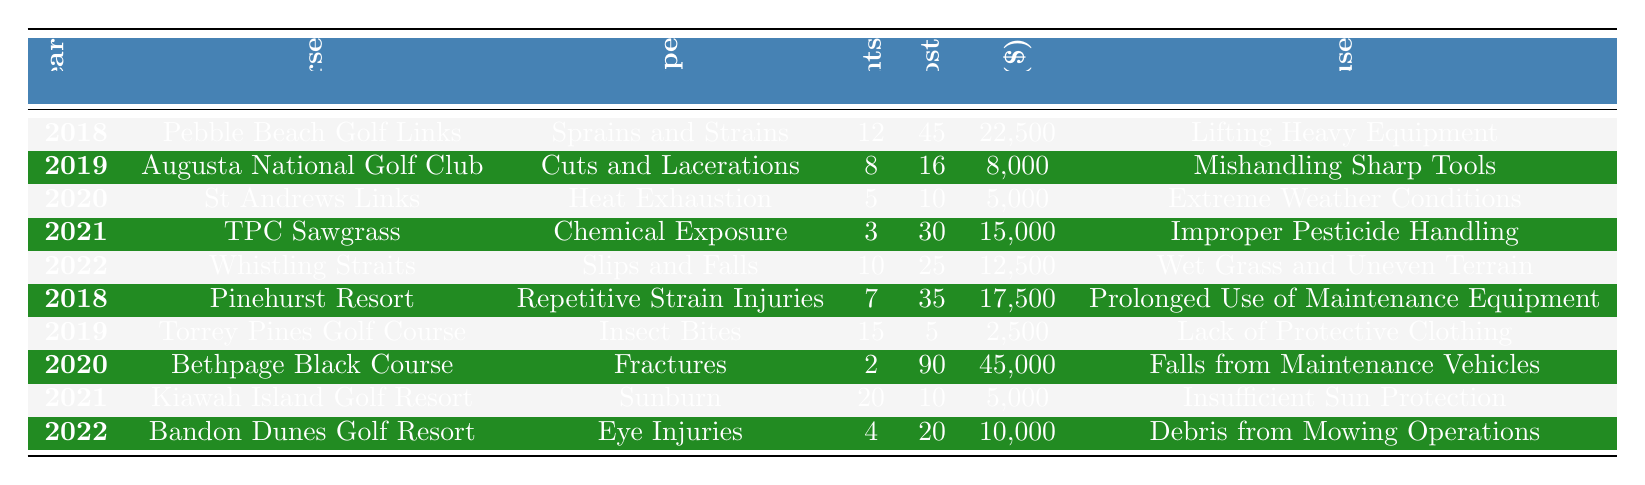What is the total number of incidents reported in 2019? The table shows that there were 8 incidents at Augusta National Golf Club and 15 incidents at Torrey Pines Golf Course in 2019. Adding these two gives 8 + 15 = 23.
Answer: 23 What type of injury had the highest cost to the golf course? Looking at the costs, the highest cost is for fractures at Bethpage Black Course, which amounts to $45,000.
Answer: Fractures How many days were lost due to chemical exposure incidents? The table indicates that there were 30 days lost for chemical exposure incidents at TPC Sawgrass.
Answer: 30 What injury type is associated with the highest number of incidents in 2021? In 2021, the injury type with the highest number of incidents is sunburn, with 20 incidents reported at Kiawah Island Golf Resort.
Answer: Sunburn Is it true that all incidents from wet grass and uneven terrain occurred in 2022? Based on the table, the only incident caused by wet grass and uneven terrain occurred in 2022, indicating that this statement is true.
Answer: Yes What was the total cost of incidents reported in 2020? In 2020, the costs were $5,000 for heat exhaustion at St Andrews Links and $45,000 for fractures at Bethpage Black Course. Summing these gives 5,000 + 45,000 = 50,000.
Answer: 50,000 How many incidents resulted in days lost greater than or equal to 25? The table shows that slips and falls in 2022 had 25 days lost, while chemical exposure in 2021 had 30 days, and fractures in 2020 had 90 days. So, there are three incidents.
Answer: 3 What was the primary cause of the highest number of reported incidents? The primary cause of the highest number of incidents is lack of protective clothing related to insect bites, which had 15 incidents in 2019.
Answer: Lack of Protective Clothing Calculate the average number of incidents per year across all years represented in the table. Summing all incidents gives 12 + 8 + 5 + 3 + 10 + 7 + 15 + 2 + 20 + 4 = 82. There are 10 years represented, so the average is 82 / 10 = 8.2.
Answer: 8.2 Which golf course had the minimum number of incidents reported? The table shows that Bethpage Black Course had the minimum number of incidents reported, with just 2 incidents for fractures in 2020.
Answer: Bethpage Black Course 